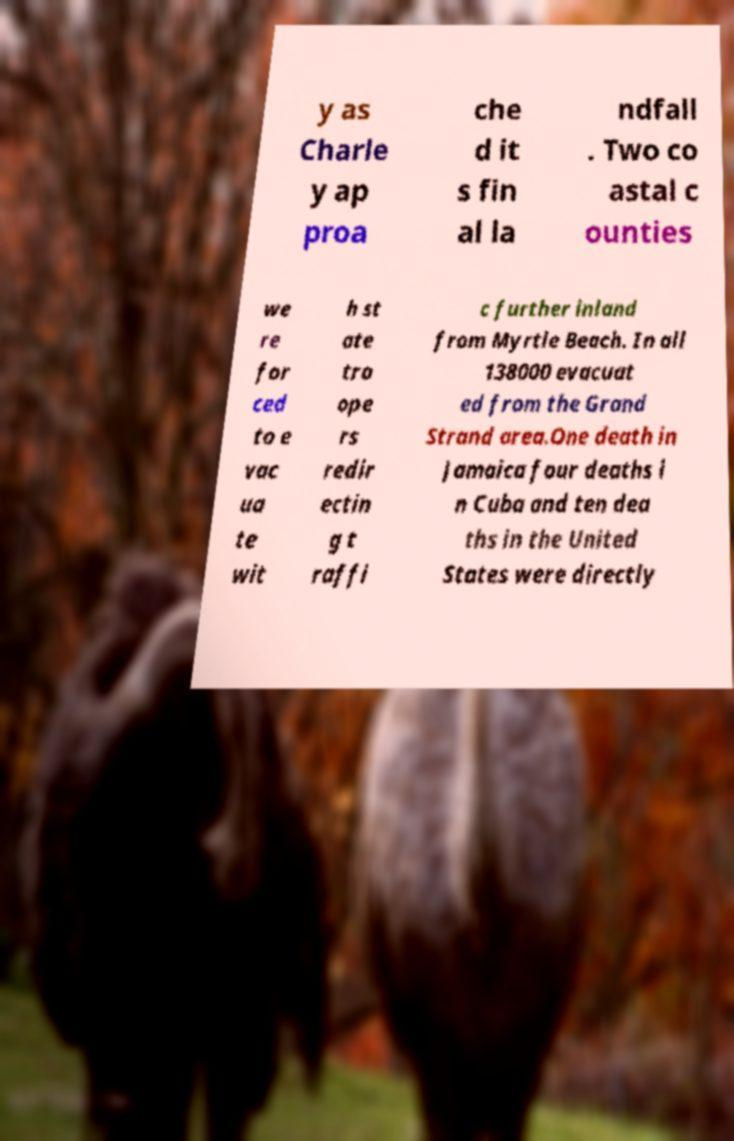Could you assist in decoding the text presented in this image and type it out clearly? y as Charle y ap proa che d it s fin al la ndfall . Two co astal c ounties we re for ced to e vac ua te wit h st ate tro ope rs redir ectin g t raffi c further inland from Myrtle Beach. In all 138000 evacuat ed from the Grand Strand area.One death in Jamaica four deaths i n Cuba and ten dea ths in the United States were directly 